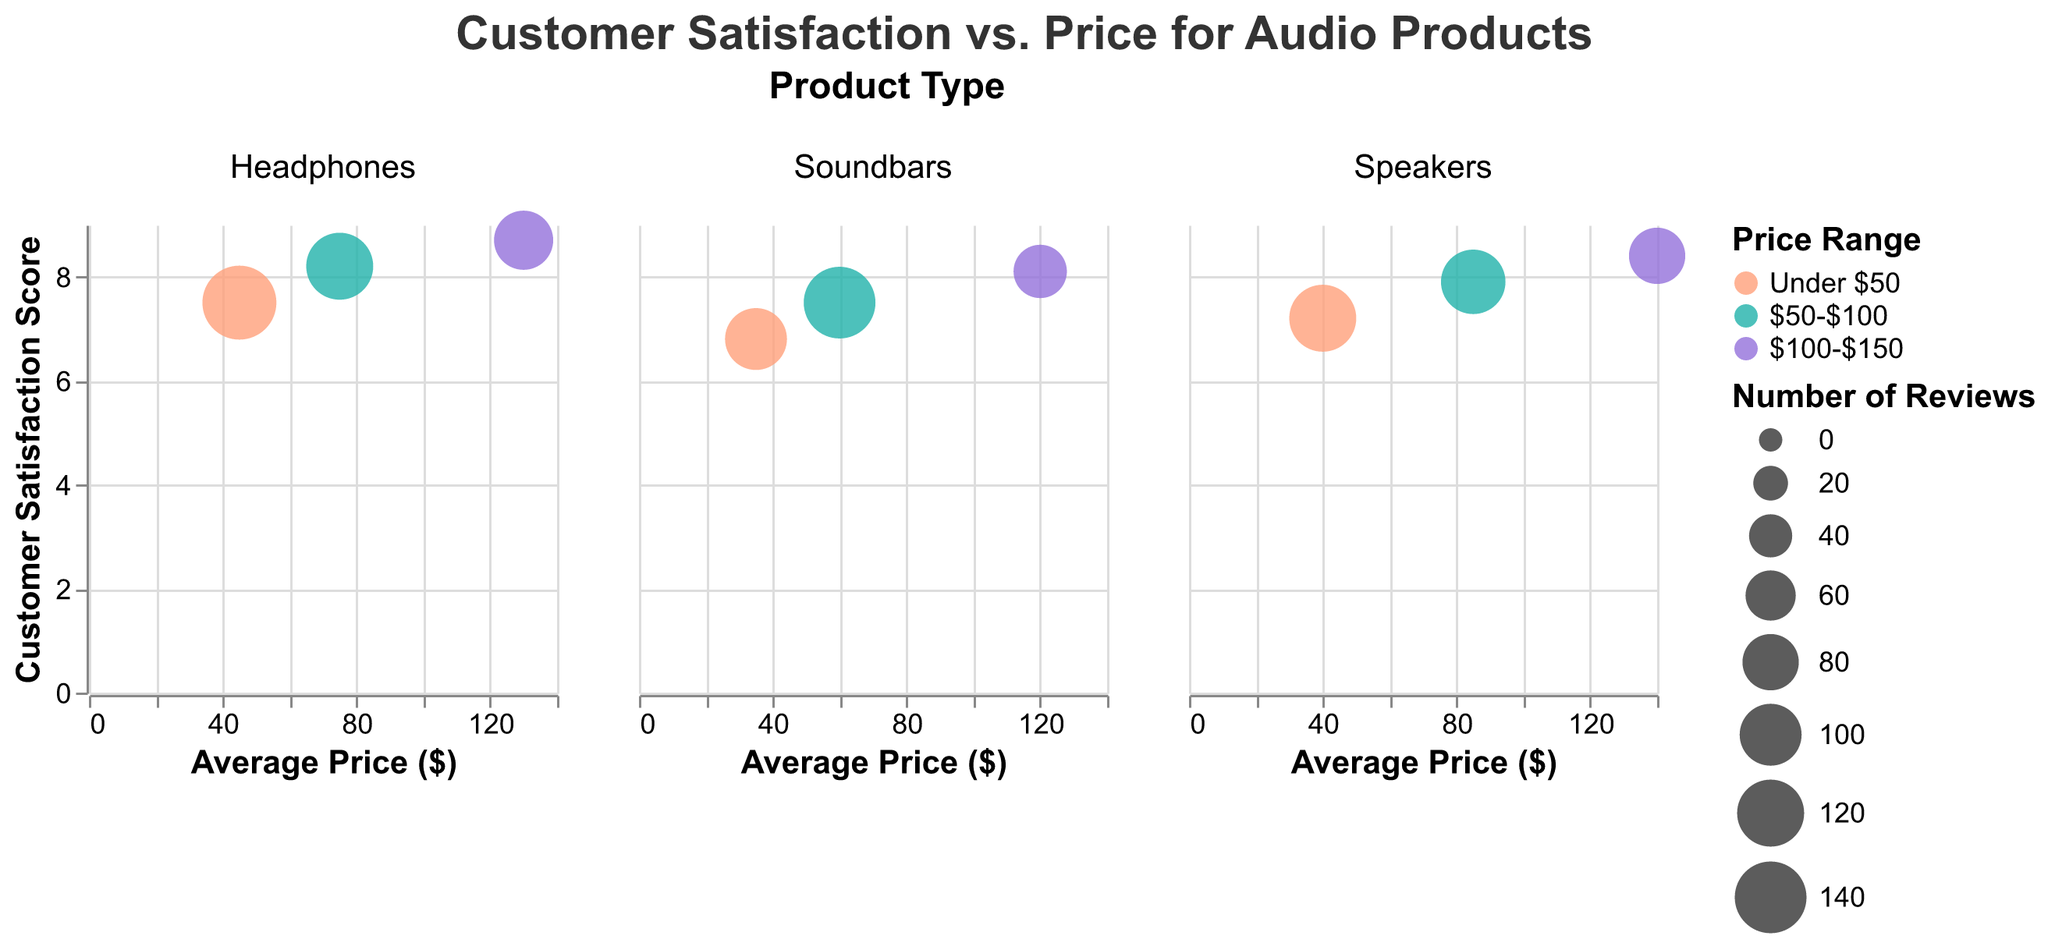How many different types of audio products are shown in the figure? The figure facets the data by product type, displaying separate plots for each type. Count the number of unique columns.
Answer: 3 What is the highest customer satisfaction score for soundbars? Look at the y-axis values in the 'Soundbars' plot and identify the highest score.
Answer: 8.1 Between headphones and speakers in the $50-$100 price range, which has a higher customer satisfaction score? Compare the customer satisfaction scores for headphones and speakers in the $50-$100 price range.
Answer: Headphones Which price range has the lowest average price for speakers? Look at the x-axis values for each price range in the 'Speakers' plot and find the lowest value.
Answer: Under $50 What is the range of customer satisfaction scores for headphones? Identify the minimum and maximum customer satisfaction scores in the 'Headphones' plot and find the difference.
Answer: 1.2 (8.7 - 7.5) Which product type has the most number of reviews in the $50-$100 price range? Look at the size of the bubbles in the $50-$100 price range across all product types and identify the largest one.
Answer: Soundbars How does the customer satisfaction score for speakers change as the price increases? Observe the trend in the 'Speakers' plot by looking at y-axis values across different average prices.
Answer: It increases Which product type has the smallest bubble, and what does it represent? Identify the smallest bubble in any of the plots and use the tooltip information to interpret data.
Answer: Soundbars, $100-$150 Is there a positive or negative correlation between average price and customer satisfaction score for headphones? Evaluate the trend of the data points in the 'Headphones' plot to determine the correlation.
Answer: Positive Between the "Under $50" and "$100-$150" price ranges, which has a larger range of customer satisfaction scores for soundbars? Compare the difference between highest and lowest scores in "Under $50" and "$100-$150" for soundbars.
Answer: Under $50 (6.8 - 8.1 = 1.3) 